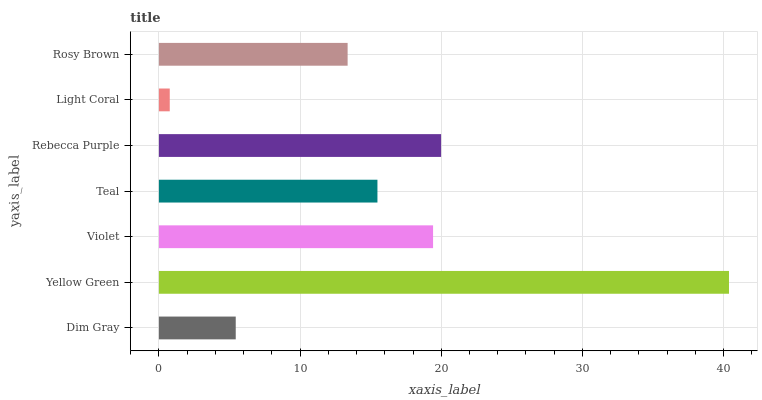Is Light Coral the minimum?
Answer yes or no. Yes. Is Yellow Green the maximum?
Answer yes or no. Yes. Is Violet the minimum?
Answer yes or no. No. Is Violet the maximum?
Answer yes or no. No. Is Yellow Green greater than Violet?
Answer yes or no. Yes. Is Violet less than Yellow Green?
Answer yes or no. Yes. Is Violet greater than Yellow Green?
Answer yes or no. No. Is Yellow Green less than Violet?
Answer yes or no. No. Is Teal the high median?
Answer yes or no. Yes. Is Teal the low median?
Answer yes or no. Yes. Is Rosy Brown the high median?
Answer yes or no. No. Is Yellow Green the low median?
Answer yes or no. No. 